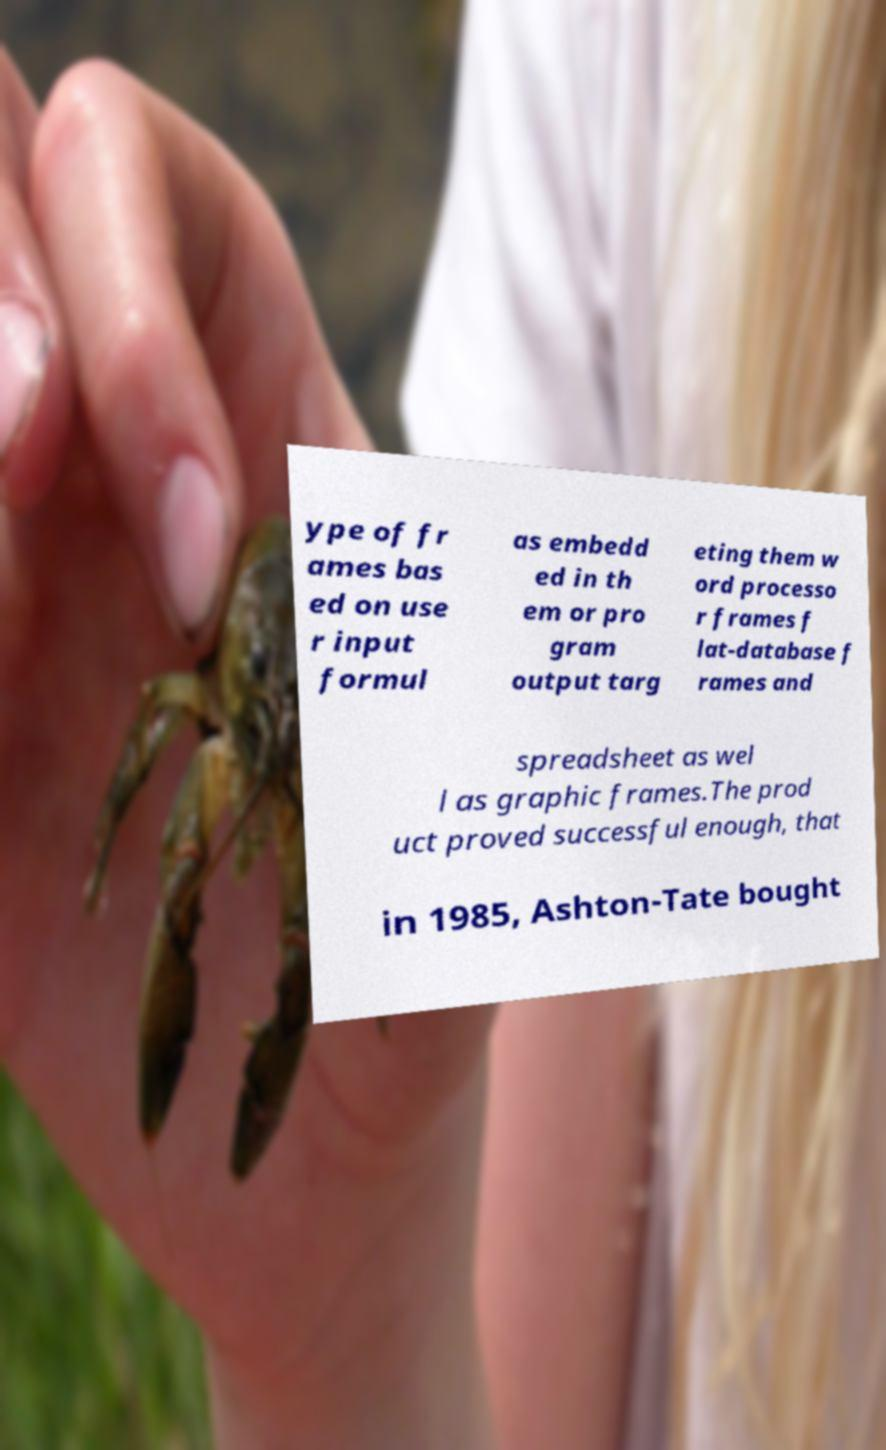What messages or text are displayed in this image? I need them in a readable, typed format. ype of fr ames bas ed on use r input formul as embedd ed in th em or pro gram output targ eting them w ord processo r frames f lat-database f rames and spreadsheet as wel l as graphic frames.The prod uct proved successful enough, that in 1985, Ashton-Tate bought 